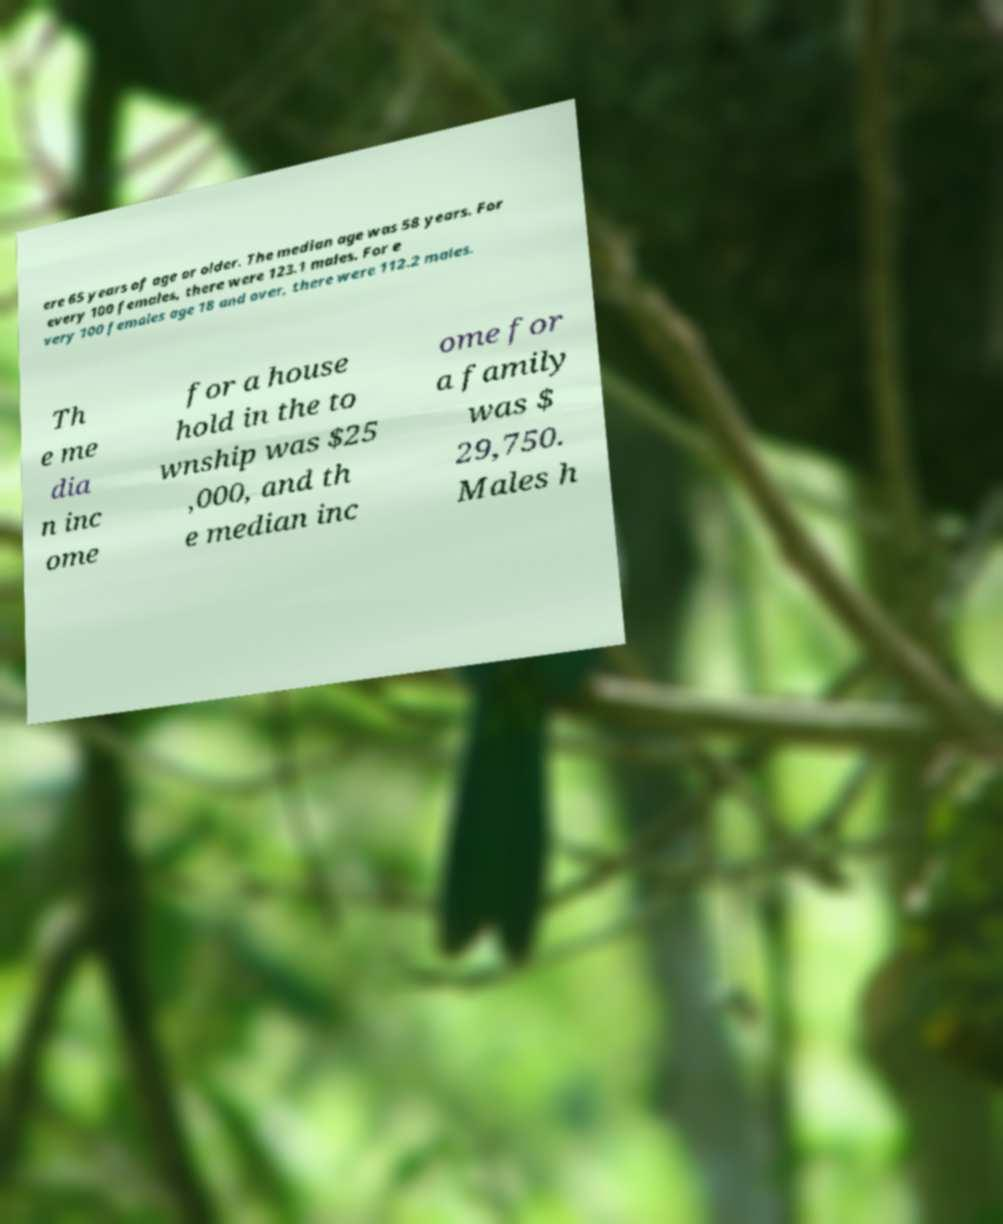Please identify and transcribe the text found in this image. ere 65 years of age or older. The median age was 58 years. For every 100 females, there were 123.1 males. For e very 100 females age 18 and over, there were 112.2 males. Th e me dia n inc ome for a house hold in the to wnship was $25 ,000, and th e median inc ome for a family was $ 29,750. Males h 